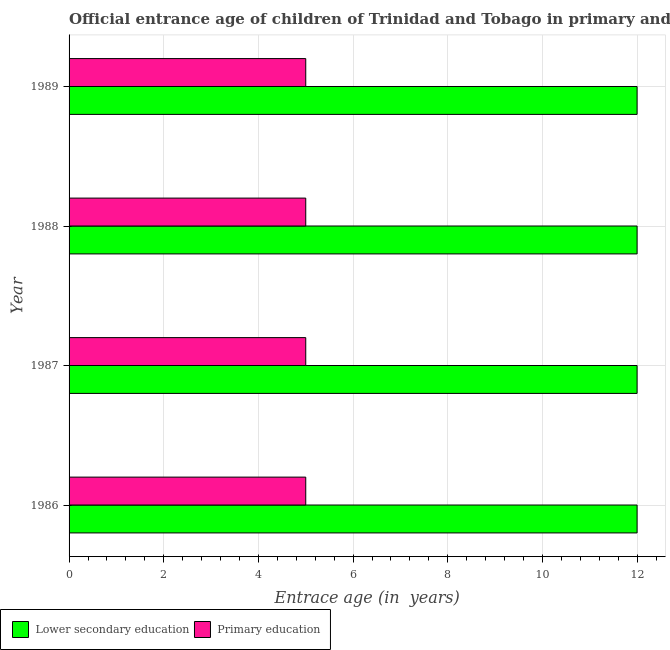Are the number of bars on each tick of the Y-axis equal?
Your response must be concise. Yes. In how many cases, is the number of bars for a given year not equal to the number of legend labels?
Your answer should be compact. 0. What is the entrance age of chiildren in primary education in 1989?
Your answer should be very brief. 5. Across all years, what is the maximum entrance age of chiildren in primary education?
Provide a succinct answer. 5. Across all years, what is the minimum entrance age of chiildren in primary education?
Provide a succinct answer. 5. In which year was the entrance age of chiildren in primary education minimum?
Make the answer very short. 1986. What is the total entrance age of chiildren in primary education in the graph?
Give a very brief answer. 20. What is the difference between the entrance age of children in lower secondary education in 1986 and the entrance age of chiildren in primary education in 1987?
Offer a very short reply. 7. In the year 1988, what is the difference between the entrance age of children in lower secondary education and entrance age of chiildren in primary education?
Give a very brief answer. 7. Is the entrance age of chiildren in primary education in 1987 less than that in 1989?
Offer a terse response. No. Is the difference between the entrance age of chiildren in primary education in 1986 and 1989 greater than the difference between the entrance age of children in lower secondary education in 1986 and 1989?
Offer a very short reply. No. What is the difference between the highest and the second highest entrance age of children in lower secondary education?
Your answer should be very brief. 0. What is the difference between the highest and the lowest entrance age of chiildren in primary education?
Give a very brief answer. 0. What does the 2nd bar from the top in 1988 represents?
Your answer should be very brief. Lower secondary education. What is the difference between two consecutive major ticks on the X-axis?
Your response must be concise. 2. Does the graph contain any zero values?
Give a very brief answer. No. Does the graph contain grids?
Make the answer very short. Yes. How are the legend labels stacked?
Ensure brevity in your answer.  Horizontal. What is the title of the graph?
Provide a short and direct response. Official entrance age of children of Trinidad and Tobago in primary and secondary education. What is the label or title of the X-axis?
Offer a very short reply. Entrace age (in  years). What is the Entrace age (in  years) of Lower secondary education in 1986?
Ensure brevity in your answer.  12. What is the Entrace age (in  years) of Primary education in 1987?
Offer a terse response. 5. What is the Entrace age (in  years) in Lower secondary education in 1988?
Your answer should be very brief. 12. What is the Entrace age (in  years) of Primary education in 1988?
Keep it short and to the point. 5. What is the Entrace age (in  years) in Lower secondary education in 1989?
Keep it short and to the point. 12. What is the Entrace age (in  years) of Primary education in 1989?
Provide a succinct answer. 5. Across all years, what is the maximum Entrace age (in  years) of Lower secondary education?
Provide a succinct answer. 12. Across all years, what is the maximum Entrace age (in  years) of Primary education?
Make the answer very short. 5. Across all years, what is the minimum Entrace age (in  years) of Lower secondary education?
Ensure brevity in your answer.  12. What is the difference between the Entrace age (in  years) in Primary education in 1986 and that in 1987?
Give a very brief answer. 0. What is the difference between the Entrace age (in  years) in Lower secondary education in 1986 and that in 1989?
Offer a terse response. 0. What is the difference between the Entrace age (in  years) in Lower secondary education in 1987 and that in 1988?
Offer a very short reply. 0. What is the difference between the Entrace age (in  years) in Lower secondary education in 1987 and that in 1989?
Offer a very short reply. 0. What is the difference between the Entrace age (in  years) of Primary education in 1987 and that in 1989?
Your answer should be compact. 0. What is the difference between the Entrace age (in  years) of Lower secondary education in 1986 and the Entrace age (in  years) of Primary education in 1987?
Give a very brief answer. 7. What is the difference between the Entrace age (in  years) in Lower secondary education in 1986 and the Entrace age (in  years) in Primary education in 1989?
Give a very brief answer. 7. What is the difference between the Entrace age (in  years) in Lower secondary education in 1987 and the Entrace age (in  years) in Primary education in 1989?
Make the answer very short. 7. What is the difference between the Entrace age (in  years) of Lower secondary education in 1988 and the Entrace age (in  years) of Primary education in 1989?
Ensure brevity in your answer.  7. What is the average Entrace age (in  years) of Primary education per year?
Offer a very short reply. 5. In the year 1986, what is the difference between the Entrace age (in  years) in Lower secondary education and Entrace age (in  years) in Primary education?
Ensure brevity in your answer.  7. In the year 1987, what is the difference between the Entrace age (in  years) of Lower secondary education and Entrace age (in  years) of Primary education?
Provide a short and direct response. 7. What is the ratio of the Entrace age (in  years) in Lower secondary education in 1986 to that in 1987?
Your response must be concise. 1. What is the ratio of the Entrace age (in  years) of Lower secondary education in 1986 to that in 1988?
Make the answer very short. 1. What is the ratio of the Entrace age (in  years) in Primary education in 1986 to that in 1988?
Ensure brevity in your answer.  1. What is the ratio of the Entrace age (in  years) of Lower secondary education in 1987 to that in 1988?
Your answer should be compact. 1. What is the ratio of the Entrace age (in  years) of Primary education in 1987 to that in 1988?
Your answer should be very brief. 1. What is the ratio of the Entrace age (in  years) in Lower secondary education in 1987 to that in 1989?
Your answer should be very brief. 1. What is the ratio of the Entrace age (in  years) of Primary education in 1987 to that in 1989?
Provide a short and direct response. 1. What is the ratio of the Entrace age (in  years) in Lower secondary education in 1988 to that in 1989?
Give a very brief answer. 1. What is the difference between the highest and the second highest Entrace age (in  years) of Primary education?
Offer a terse response. 0. 